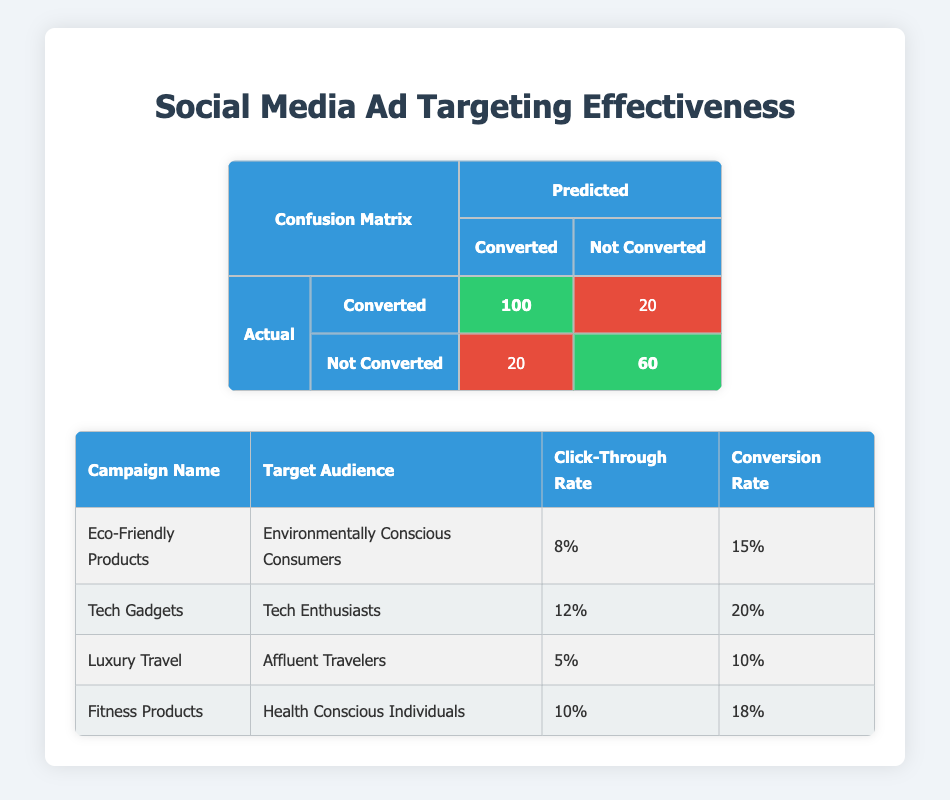What is the number of True Positives in the confusion matrix? The confusion matrix shows 100 True Positives, which are the instances where the model correctly predicted conversions.
Answer: 100 What is the number of False Negatives? The confusion matrix displays 20 False Negatives, indicating the instances where the model failed to predict conversions that actually occurred.
Answer: 20 Which campaign has the highest conversion rate? By comparing the conversion rates in the table, the "Tech Gadgets" campaign has the highest conversion rate at 20%.
Answer: Tech Gadgets What is the total number of actual conversions? The total number of actual conversions is given as 120 in the confusion matrix under the 'Converted' category.
Answer: 120 Is the click-through rate for the "Luxury Travel" campaign greater than 10%? The table shows a click-through rate of 5% for the "Luxury Travel" campaign, which is less than 10%.
Answer: No What is the total number of predictions made by the model? To find the total predictions, we can sum True Positives (100) + False Positives (20) + False Negatives (20) + True Negatives (60). This equals 300 predictions.
Answer: 300 What is the average click-through rate of all campaigns? To find the average click-through rate, we add the click-through rates (8% + 12% + 5% + 10% = 35%) and then divide by the number of campaigns (4). So, 35% / 4 = 8.75%.
Answer: 8.75% If we combine the results for "Eco-Friendly Products" and "Fitness Products", what is their total conversion rate? The conversion rates for these two campaigns are 15% and 18% respectively. Adding these gives us a total of 33%. Therefore, the combined conversion rate is 33%.
Answer: 33% Which campaign's target audience is the "Health Conscious Individuals"? From the campaign table, the "Fitness Products" campaign targets "Health Conscious Individuals".
Answer: Fitness Products 